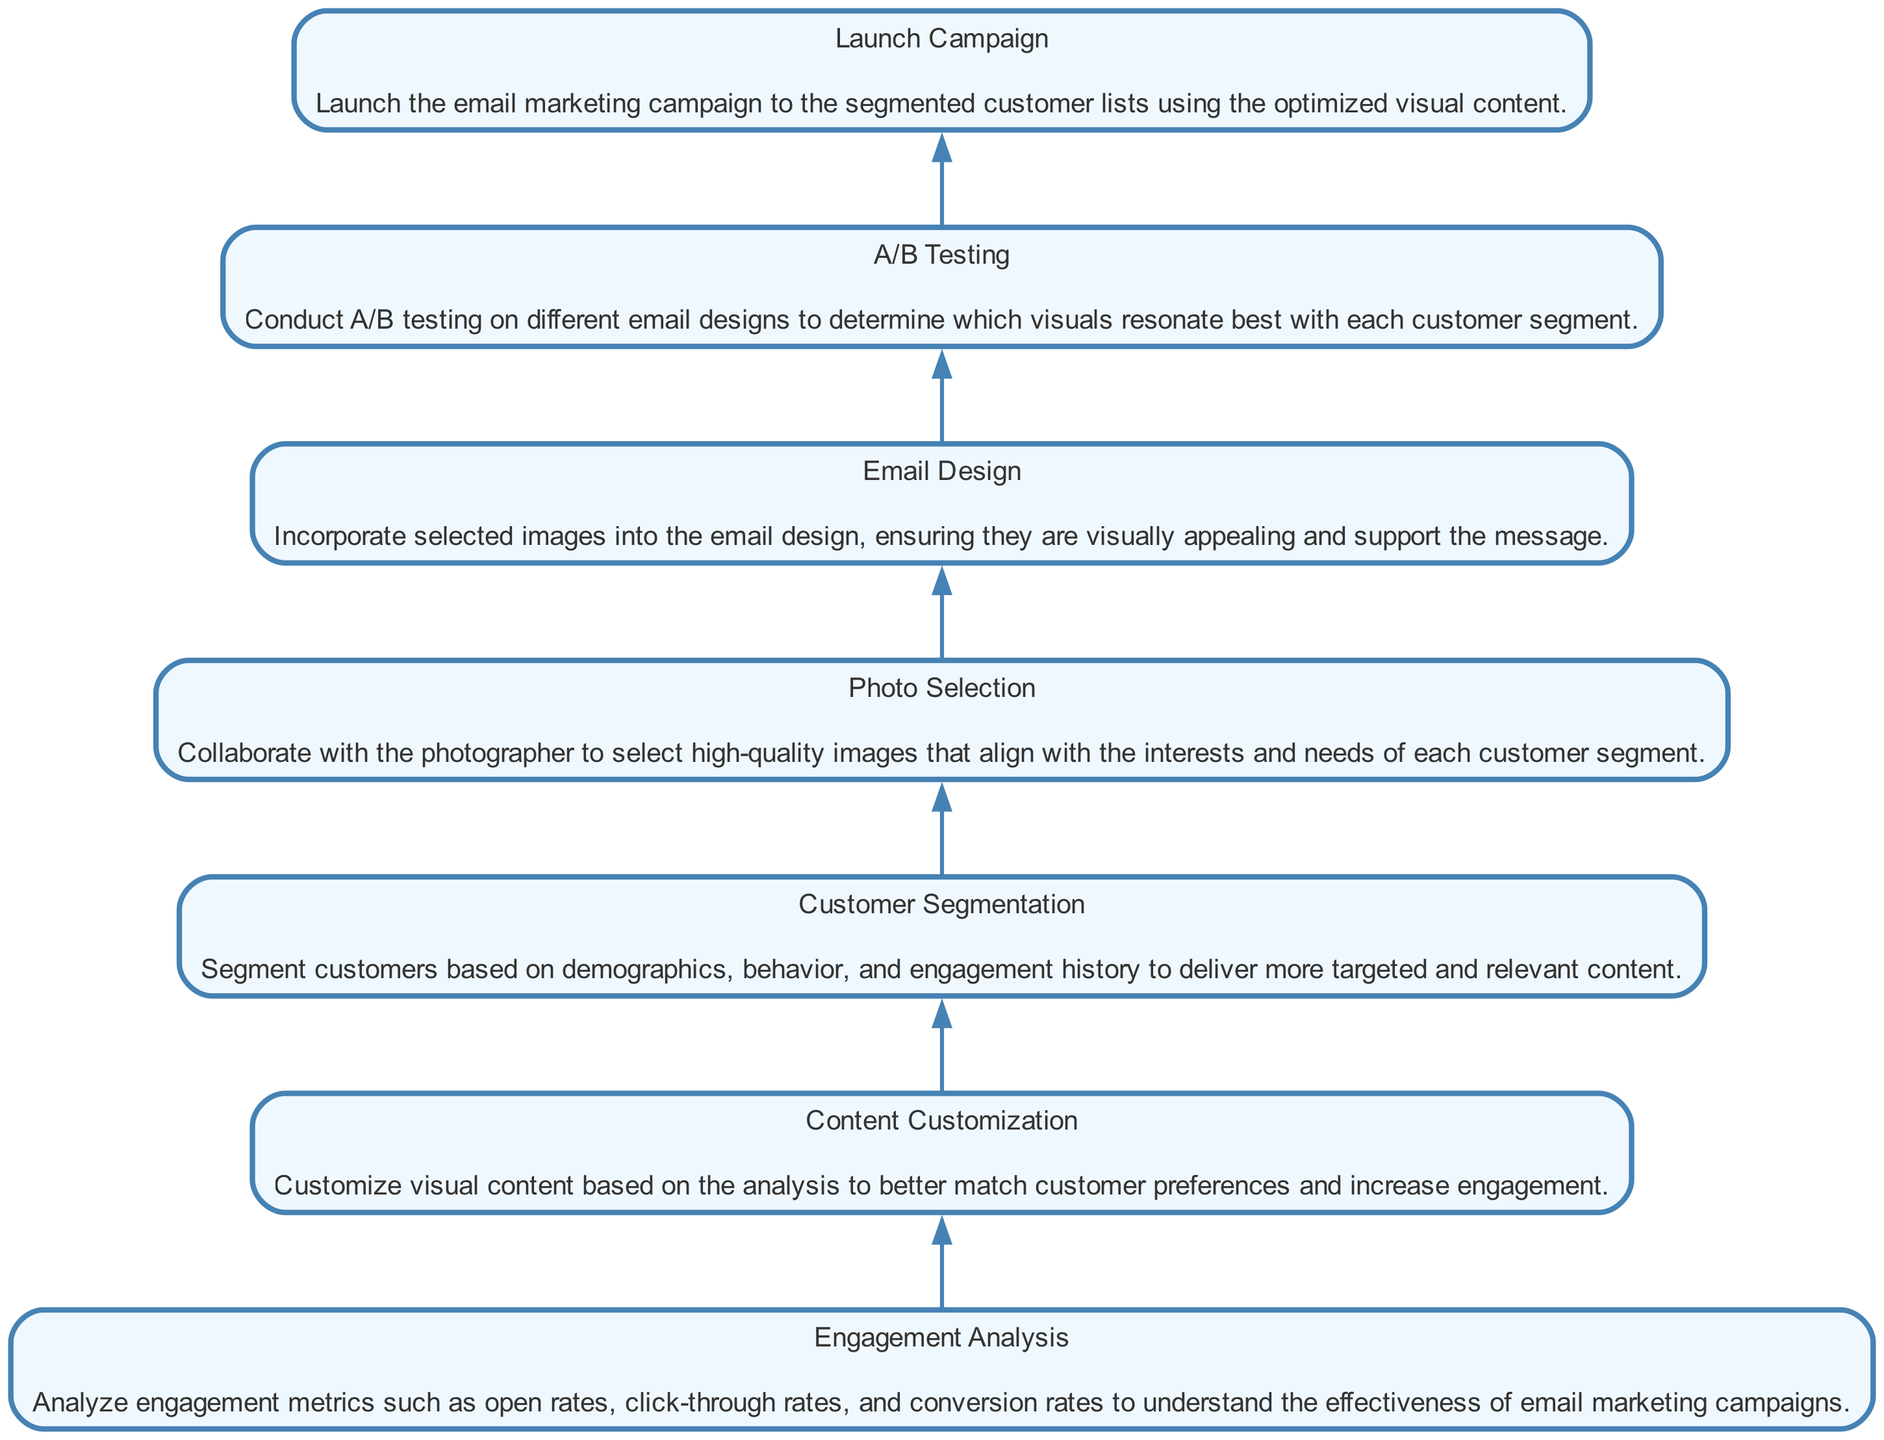What is the first step in the flow? The first step in the flow, as indicated by the bottom of the diagram, is "Engagement Analysis." This is the initial process before any other actions take place.
Answer: Engagement Analysis How many nodes are in the diagram? Counting all the distinct steps represented in the diagram, there are seven nodes that outline the email marketing strategy.
Answer: Seven What is the last step in the process? The last step depicted at the top of the diagram is "Launch Campaign," which signifies the final action after all preceding steps have been completed.
Answer: Launch Campaign Which step comes before "Photo Selection"? "Customer Segmentation" directly precedes "Photo Selection" in the sequence of operations depicted in the diagram.
Answer: Customer Segmentation What action follows "A/B Testing"? After "A/B Testing," the subsequent action is to "Launch Campaign," indicating the progression from testing to execution of the marketing strategy.
Answer: Launch Campaign What is the significance of "Content Customization"? "Content Customization" plays a crucial role as it tailors visual content according to the analyzed engagement metrics, making it essential for increasing customer engagement.
Answer: Tailoring visuals Which step involves collaborating with the photographer? The step that involves collaboration with the photographer is "Photo Selection," where high-quality images are chosen according to customer interests.
Answer: Photo Selection What is the purpose of "A/B Testing"? The purpose of "A/B Testing" is to determine which email designs and visuals resonate best with each customer segment, helping refine content effectiveness.
Answer: Determine effectiveness How does "Customer Segmentation" relate to "Engagement Analysis"? "Customer Segmentation" follows "Engagement Analysis" and uses the insights gained from the analysis to strategically target specific customer groups for improved marketing.
Answer: Strategic targeting 